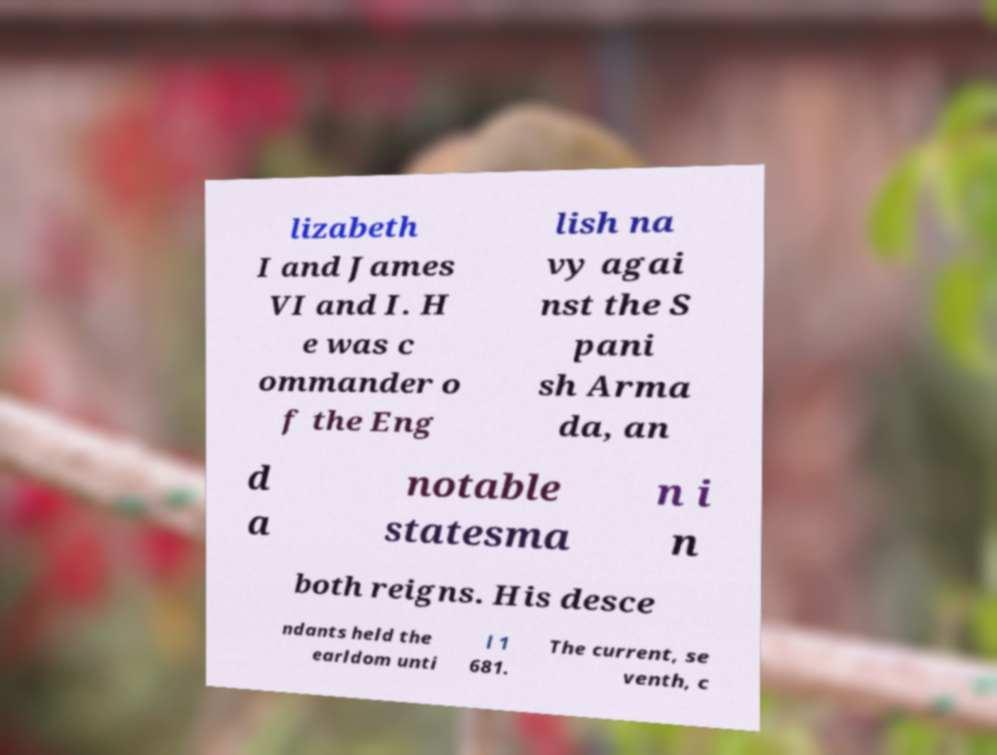There's text embedded in this image that I need extracted. Can you transcribe it verbatim? lizabeth I and James VI and I. H e was c ommander o f the Eng lish na vy agai nst the S pani sh Arma da, an d a notable statesma n i n both reigns. His desce ndants held the earldom unti l 1 681. The current, se venth, c 